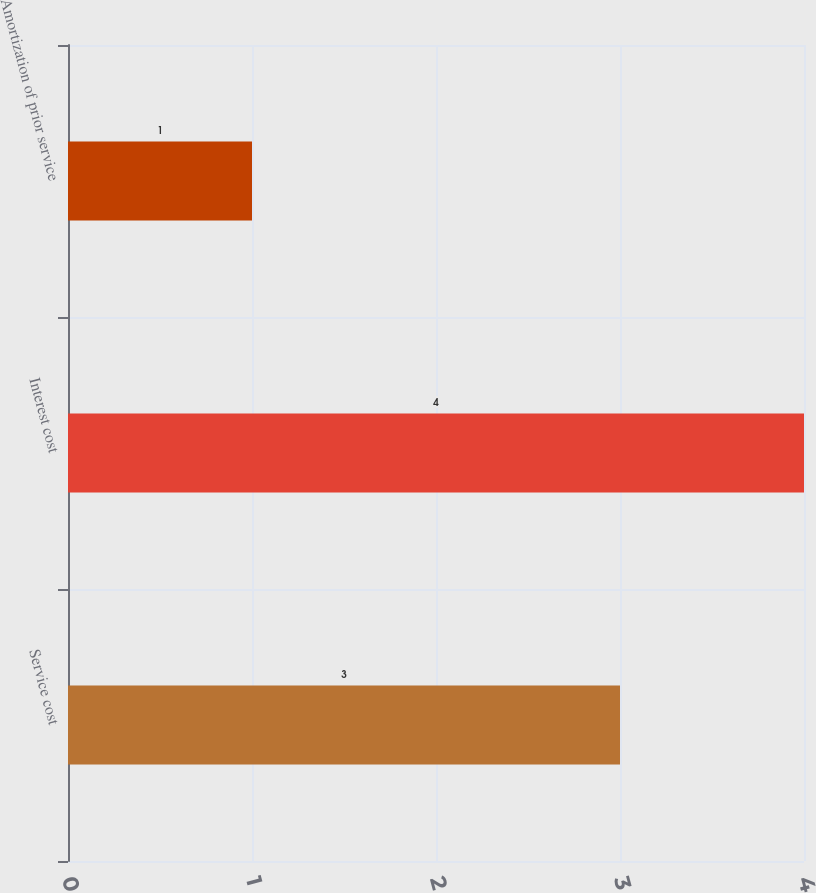Convert chart to OTSL. <chart><loc_0><loc_0><loc_500><loc_500><bar_chart><fcel>Service cost<fcel>Interest cost<fcel>Amortization of prior service<nl><fcel>3<fcel>4<fcel>1<nl></chart> 